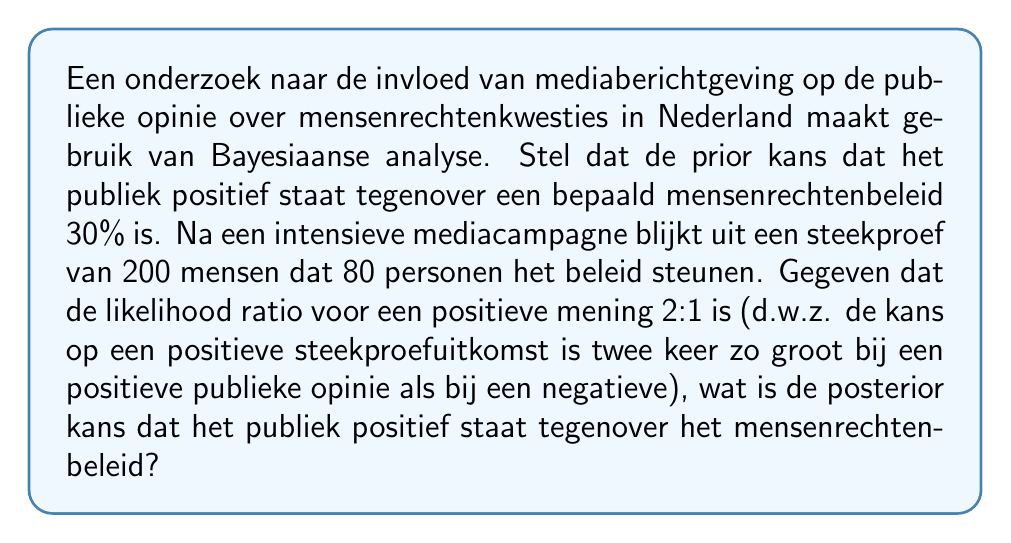Teach me how to tackle this problem. Om deze vraag op te lossen, gebruiken we Bayes' theorem:

$$P(A|B) = \frac{P(B|A) \cdot P(A)}{P(B)}$$

Waar:
A = positieve publieke opinie
B = steekproefresultaat

Gegeven:
- Prior kans: $P(A) = 0.30$
- Likelihood ratio: $\frac{P(B|A)}{P(B|\neg A)} = 2$
- Steekproefresultaat: 80 uit 200 positief

Stap 1: Bereken $P(B|A)$ en $P(B|\neg A)$
Laat $x = P(B|A)$, dan is $P(B|\neg A) = \frac{x}{2}$

$P(B) = P(B|A) \cdot P(A) + P(B|\neg A) \cdot P(\neg A)$
$\frac{80}{200} = x \cdot 0.30 + \frac{x}{2} \cdot 0.70$
$0.4 = 0.30x + 0.35x$
$0.4 = 0.65x$
$x = \frac{0.4}{0.65} \approx 0.6154$

Dus, $P(B|A) \approx 0.6154$ en $P(B|\neg A) \approx 0.3077$

Stap 2: Bereken $P(B)$
$P(B) = P(B|A) \cdot P(A) + P(B|\neg A) \cdot P(\neg A)$
$P(B) = 0.6154 \cdot 0.30 + 0.3077 \cdot 0.70 = 0.4$

Stap 3: Pas Bayes' theorem toe
$$P(A|B) = \frac{P(B|A) \cdot P(A)}{P(B)} = \frac{0.6154 \cdot 0.30}{0.4} \approx 0.4615$$

De posterior kans dat het publiek positief staat tegenover het mensenrechtenbeleid is dus ongeveer 46.15%.
Answer: De posterior kans dat het publiek positief staat tegenover het mensenrechtenbeleid is ongeveer 46.15%. 